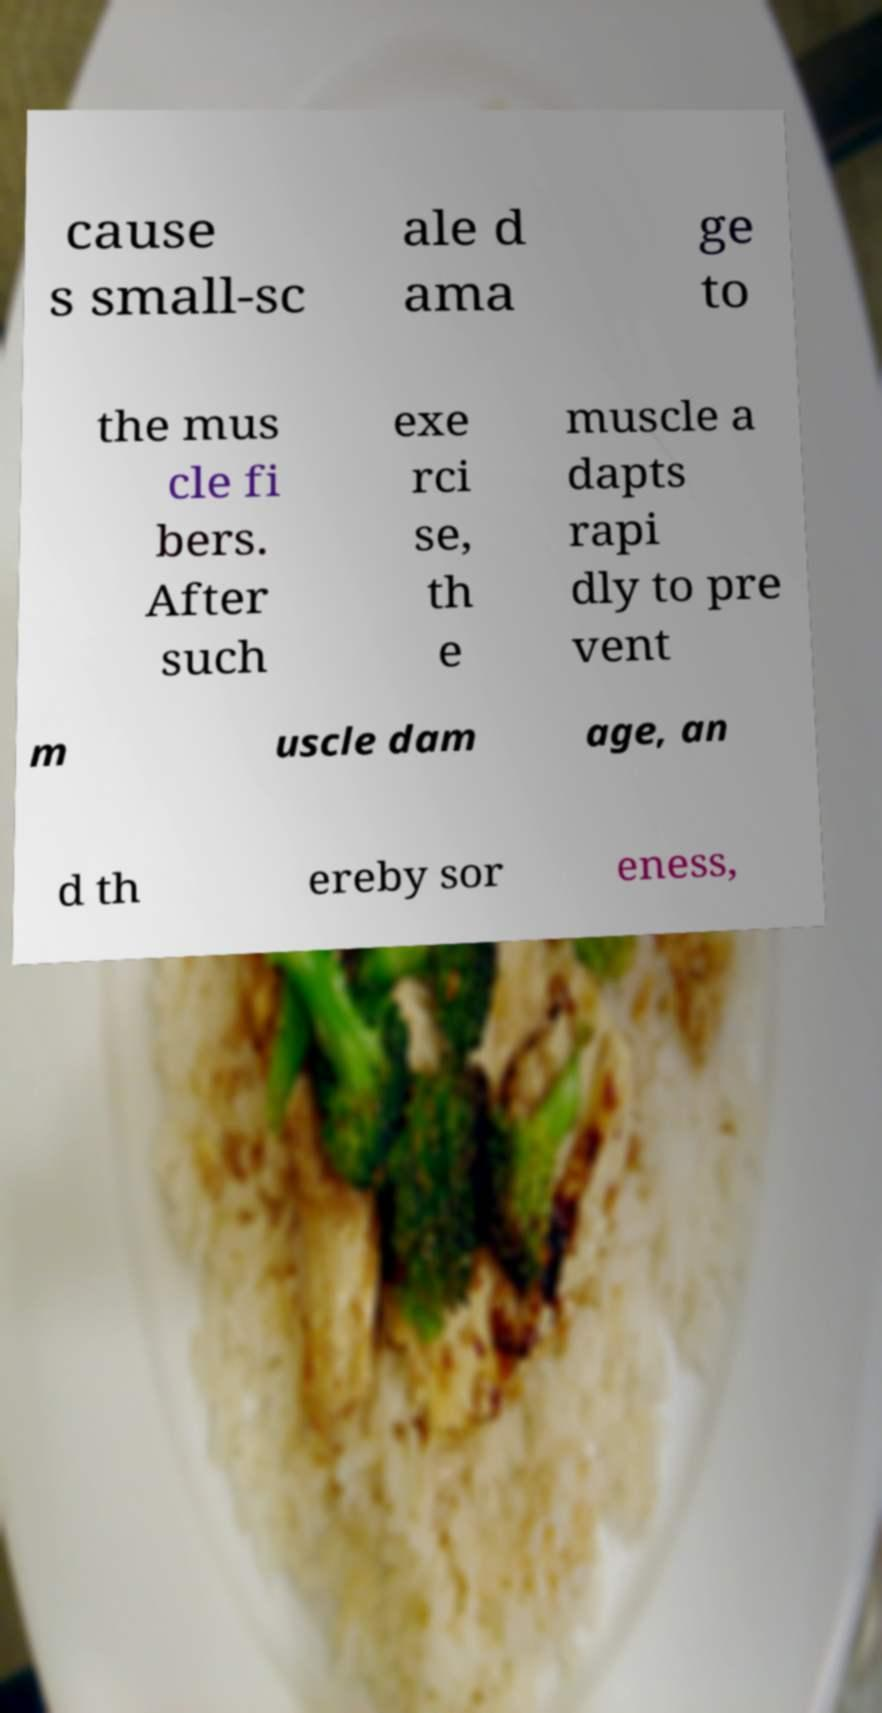There's text embedded in this image that I need extracted. Can you transcribe it verbatim? cause s small-sc ale d ama ge to the mus cle fi bers. After such exe rci se, th e muscle a dapts rapi dly to pre vent m uscle dam age, an d th ereby sor eness, 